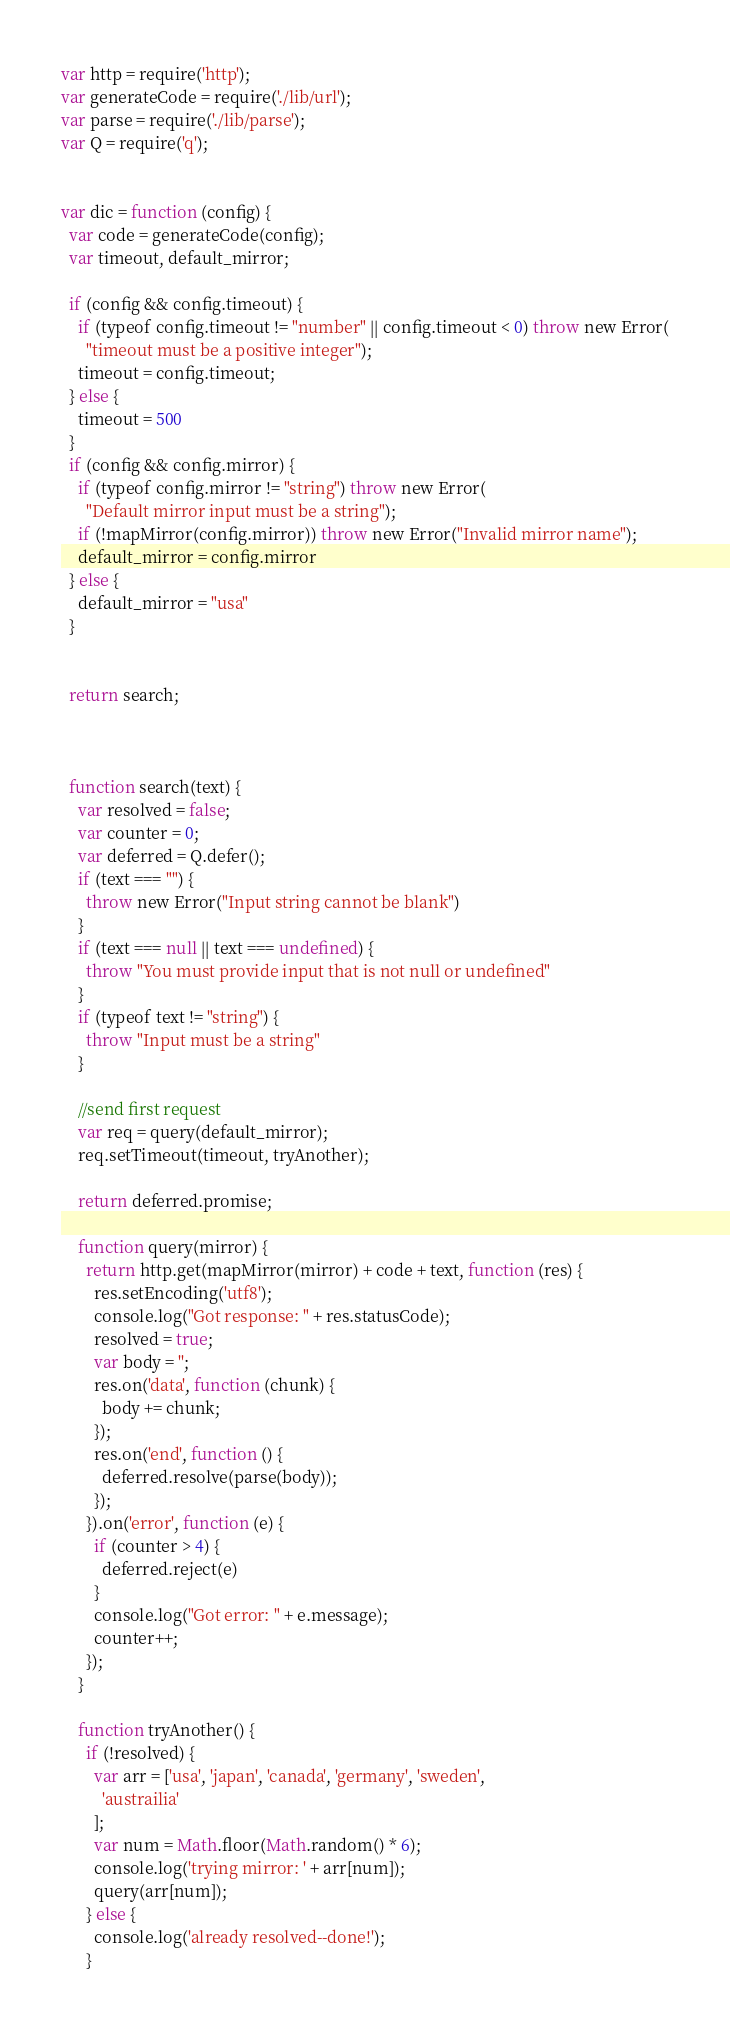Convert code to text. <code><loc_0><loc_0><loc_500><loc_500><_JavaScript_>var http = require('http');
var generateCode = require('./lib/url');
var parse = require('./lib/parse');
var Q = require('q');


var dic = function (config) {
  var code = generateCode(config);
  var timeout, default_mirror;

  if (config && config.timeout) {
    if (typeof config.timeout != "number" || config.timeout < 0) throw new Error(
      "timeout must be a positive integer");
    timeout = config.timeout;
  } else {
    timeout = 500
  }
  if (config && config.mirror) {
    if (typeof config.mirror != "string") throw new Error(
      "Default mirror input must be a string");
    if (!mapMirror(config.mirror)) throw new Error("Invalid mirror name");
    default_mirror = config.mirror
  } else {
    default_mirror = "usa"
  }


  return search;



  function search(text) {
    var resolved = false;
    var counter = 0;
    var deferred = Q.defer();
    if (text === "") {
      throw new Error("Input string cannot be blank")
    }
    if (text === null || text === undefined) {
      throw "You must provide input that is not null or undefined"
    }
    if (typeof text != "string") {
      throw "Input must be a string"
    }

    //send first request
    var req = query(default_mirror);
    req.setTimeout(timeout, tryAnother);

    return deferred.promise;

    function query(mirror) {
      return http.get(mapMirror(mirror) + code + text, function (res) {
        res.setEncoding('utf8');
        console.log("Got response: " + res.statusCode);
        resolved = true;
        var body = '';
        res.on('data', function (chunk) {
          body += chunk;
        });
        res.on('end', function () {
          deferred.resolve(parse(body));
        });
      }).on('error', function (e) {
        if (counter > 4) {
          deferred.reject(e)
        }
        console.log("Got error: " + e.message);
        counter++;
      });
    }

    function tryAnother() {
      if (!resolved) {
        var arr = ['usa', 'japan', 'canada', 'germany', 'sweden',
          'austrailia'
        ];
        var num = Math.floor(Math.random() * 6);
        console.log('trying mirror: ' + arr[num]);
        query(arr[num]);
      } else {
        console.log('already resolved--done!');
      }</code> 